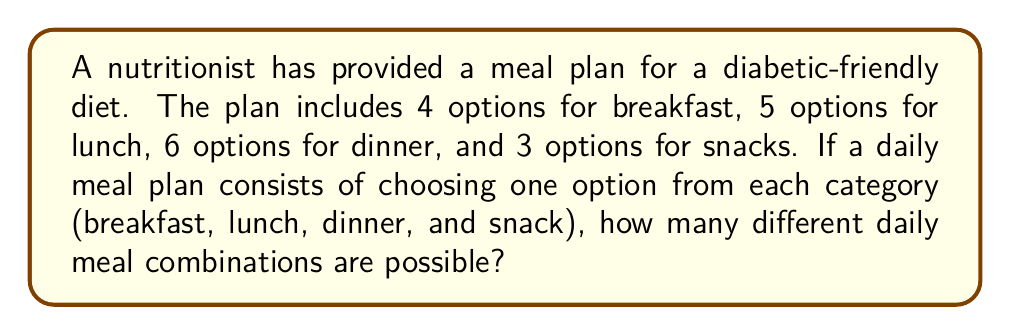Give your solution to this math problem. Let's approach this step-by-step using the multiplication principle of counting:

1) For breakfast, there are 4 options.
2) For lunch, there are 5 options.
3) For dinner, there are 6 options.
4) For snacks, there are 3 options.

According to the multiplication principle, if we have a sequence of $n$ independent choices, where:
- the first choice has $k_1$ options
- the second choice has $k_2$ options
- ...
- the $n$-th choice has $k_n$ options

Then the total number of possible outcomes is:

$$ k_1 \times k_2 \times ... \times k_n $$

In our case, we have 4 independent choices (breakfast, lunch, dinner, snack), so:

$$ \text{Total combinations} = 4 \times 5 \times 6 \times 3 $$

Calculating this:

$$ \text{Total combinations} = 360 $$

Therefore, there are 360 possible daily meal combinations for this diabetic-friendly diet plan.
Answer: 360 